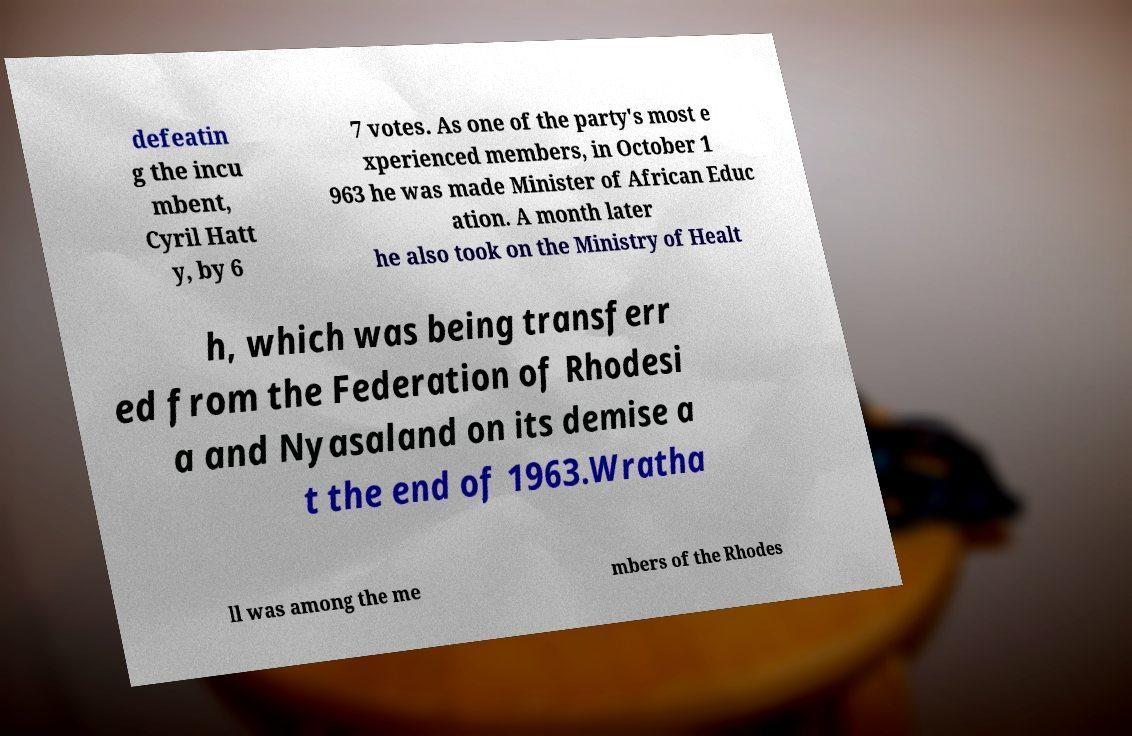Could you extract and type out the text from this image? defeatin g the incu mbent, Cyril Hatt y, by 6 7 votes. As one of the party's most e xperienced members, in October 1 963 he was made Minister of African Educ ation. A month later he also took on the Ministry of Healt h, which was being transferr ed from the Federation of Rhodesi a and Nyasaland on its demise a t the end of 1963.Wratha ll was among the me mbers of the Rhodes 